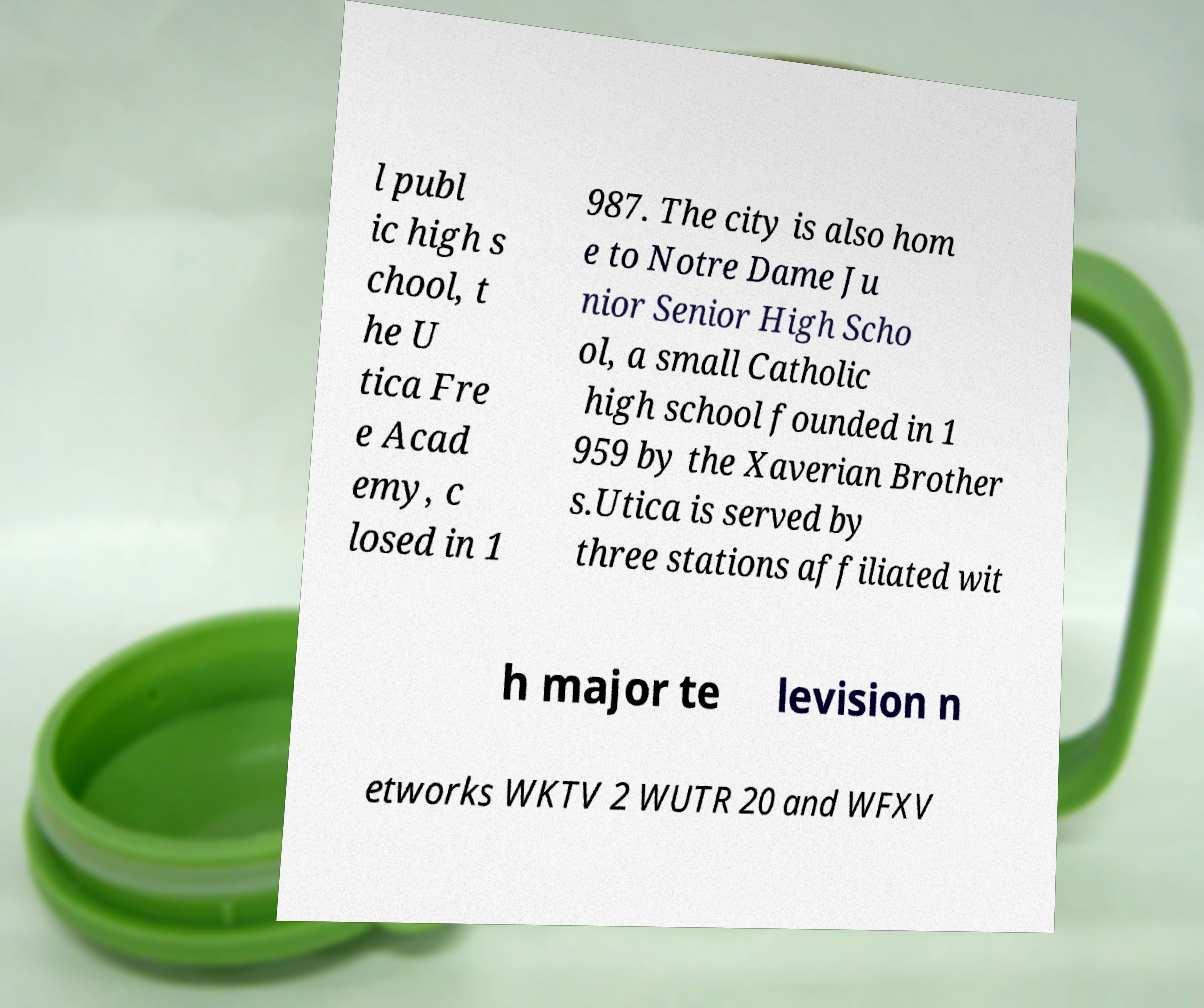Please identify and transcribe the text found in this image. l publ ic high s chool, t he U tica Fre e Acad emy, c losed in 1 987. The city is also hom e to Notre Dame Ju nior Senior High Scho ol, a small Catholic high school founded in 1 959 by the Xaverian Brother s.Utica is served by three stations affiliated wit h major te levision n etworks WKTV 2 WUTR 20 and WFXV 